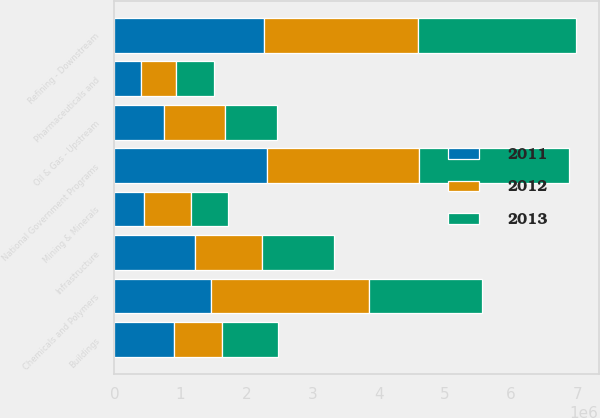<chart> <loc_0><loc_0><loc_500><loc_500><stacked_bar_chart><ecel><fcel>Chemicals and Polymers<fcel>Refining - Downstream<fcel>National Government Programs<fcel>Infrastructure<fcel>Oil & Gas - Upstream<fcel>Buildings<fcel>Mining & Minerals<fcel>Pharmaceuticals and<nl><fcel>2012<fcel>2.39114e+06<fcel>2.33739e+06<fcel>2.28453e+06<fcel>1.01586e+06<fcel>915478<fcel>738404<fcel>712320<fcel>523490<nl><fcel>2013<fcel>1.70472e+06<fcel>2.37975e+06<fcel>2.27261e+06<fcel>1.08565e+06<fcel>790546<fcel>843938<fcel>550134<fcel>576303<nl><fcel>2011<fcel>1.46112e+06<fcel>2.25609e+06<fcel>2.31324e+06<fcel>1.21963e+06<fcel>753471<fcel>893528<fcel>449194<fcel>404687<nl></chart> 